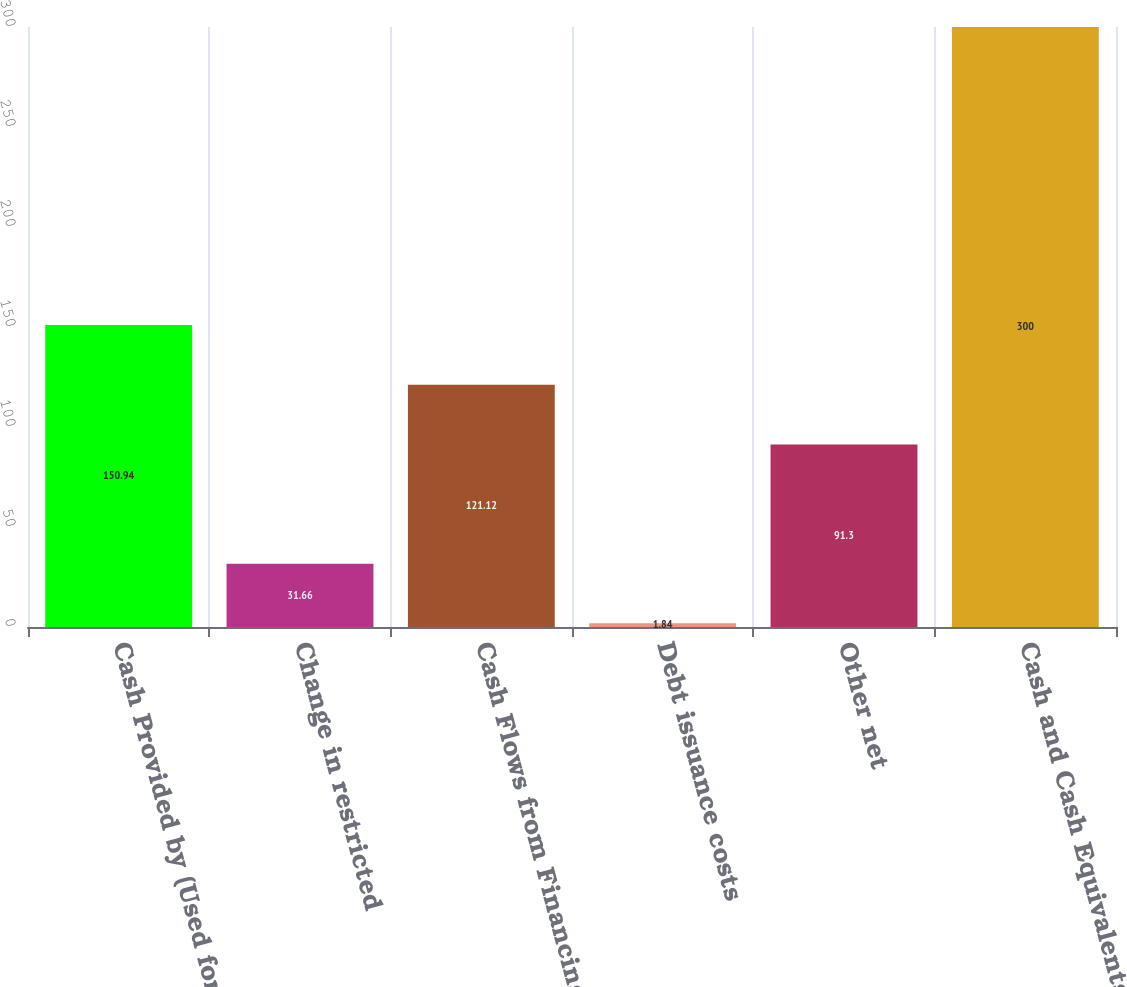Convert chart to OTSL. <chart><loc_0><loc_0><loc_500><loc_500><bar_chart><fcel>Cash Provided by (Used for)<fcel>Change in restricted<fcel>Cash Flows from Financing<fcel>Debt issuance costs<fcel>Other net<fcel>Cash and Cash Equivalents at<nl><fcel>150.94<fcel>31.66<fcel>121.12<fcel>1.84<fcel>91.3<fcel>300<nl></chart> 